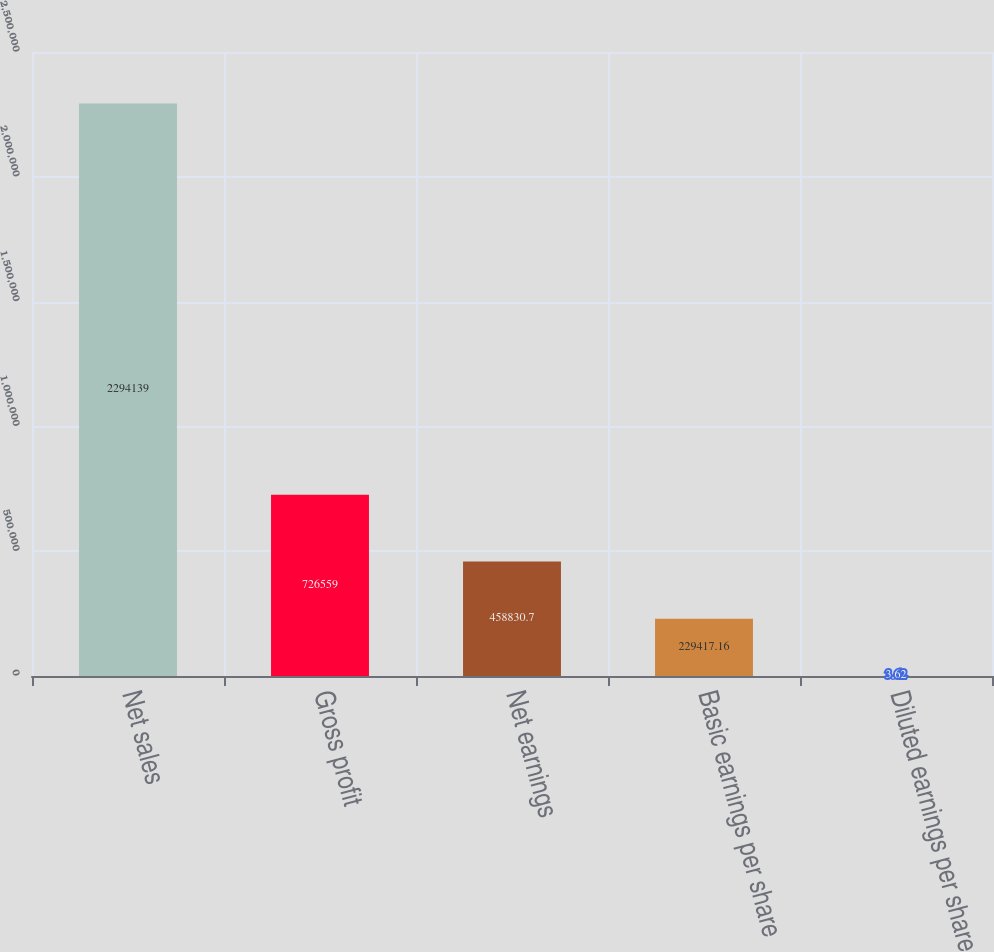Convert chart. <chart><loc_0><loc_0><loc_500><loc_500><bar_chart><fcel>Net sales<fcel>Gross profit<fcel>Net earnings<fcel>Basic earnings per share<fcel>Diluted earnings per share<nl><fcel>2.29414e+06<fcel>726559<fcel>458831<fcel>229417<fcel>3.62<nl></chart> 